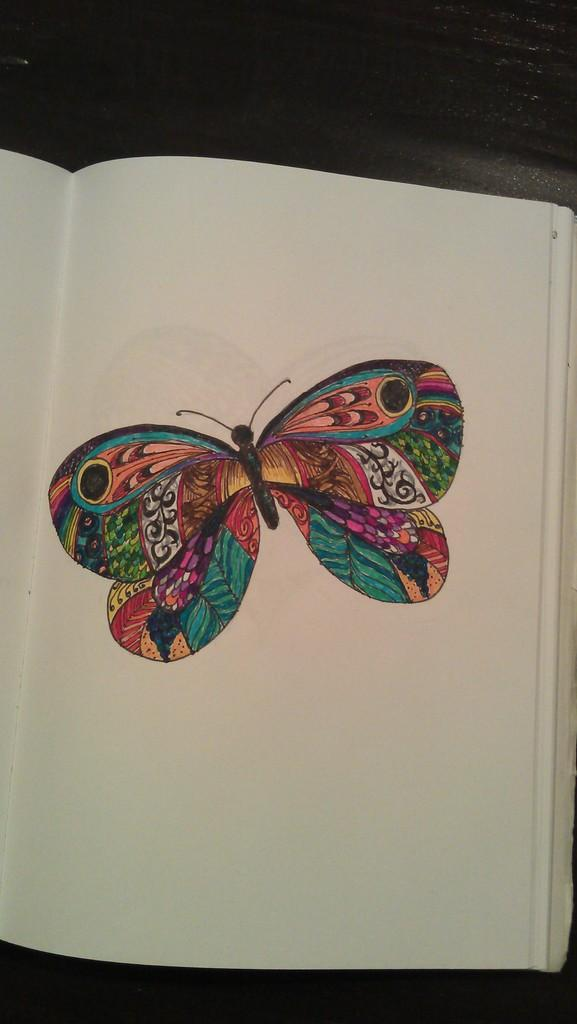What is the main subject of the image? There is a colorful butterfly in the image. Where is the butterfly located? The butterfly is on a book. What is the color of the background in the image? The background of the image is black. Can you tell me how many goldfish are swimming in the background of the image? There are no goldfish present in the image; the background is black. What type of flame can be seen near the butterfly in the image? There is no flame present in the image; it features a butterfly on a book with a black background. 